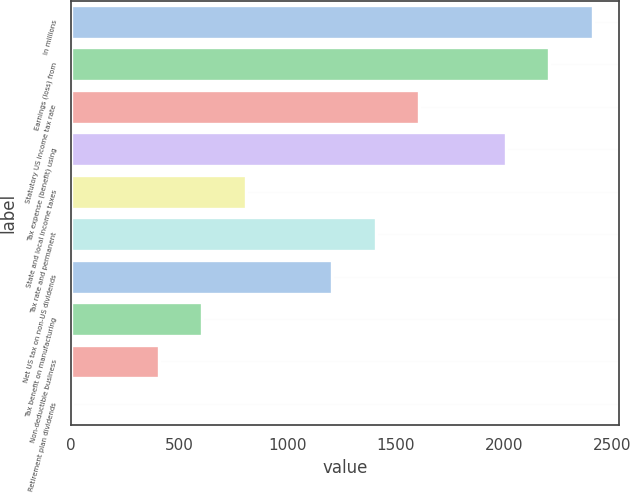<chart> <loc_0><loc_0><loc_500><loc_500><bar_chart><fcel>In millions<fcel>Earnings (loss) from<fcel>Statutory US income tax rate<fcel>Tax expense (benefit) using<fcel>State and local income taxes<fcel>Tax rate and permanent<fcel>Net US tax on non-US dividends<fcel>Tax benefit on manufacturing<fcel>Non-deductible business<fcel>Retirement plan dividends<nl><fcel>2412.2<fcel>2211.6<fcel>1609.8<fcel>2011<fcel>807.4<fcel>1409.2<fcel>1208.6<fcel>606.8<fcel>406.2<fcel>5<nl></chart> 